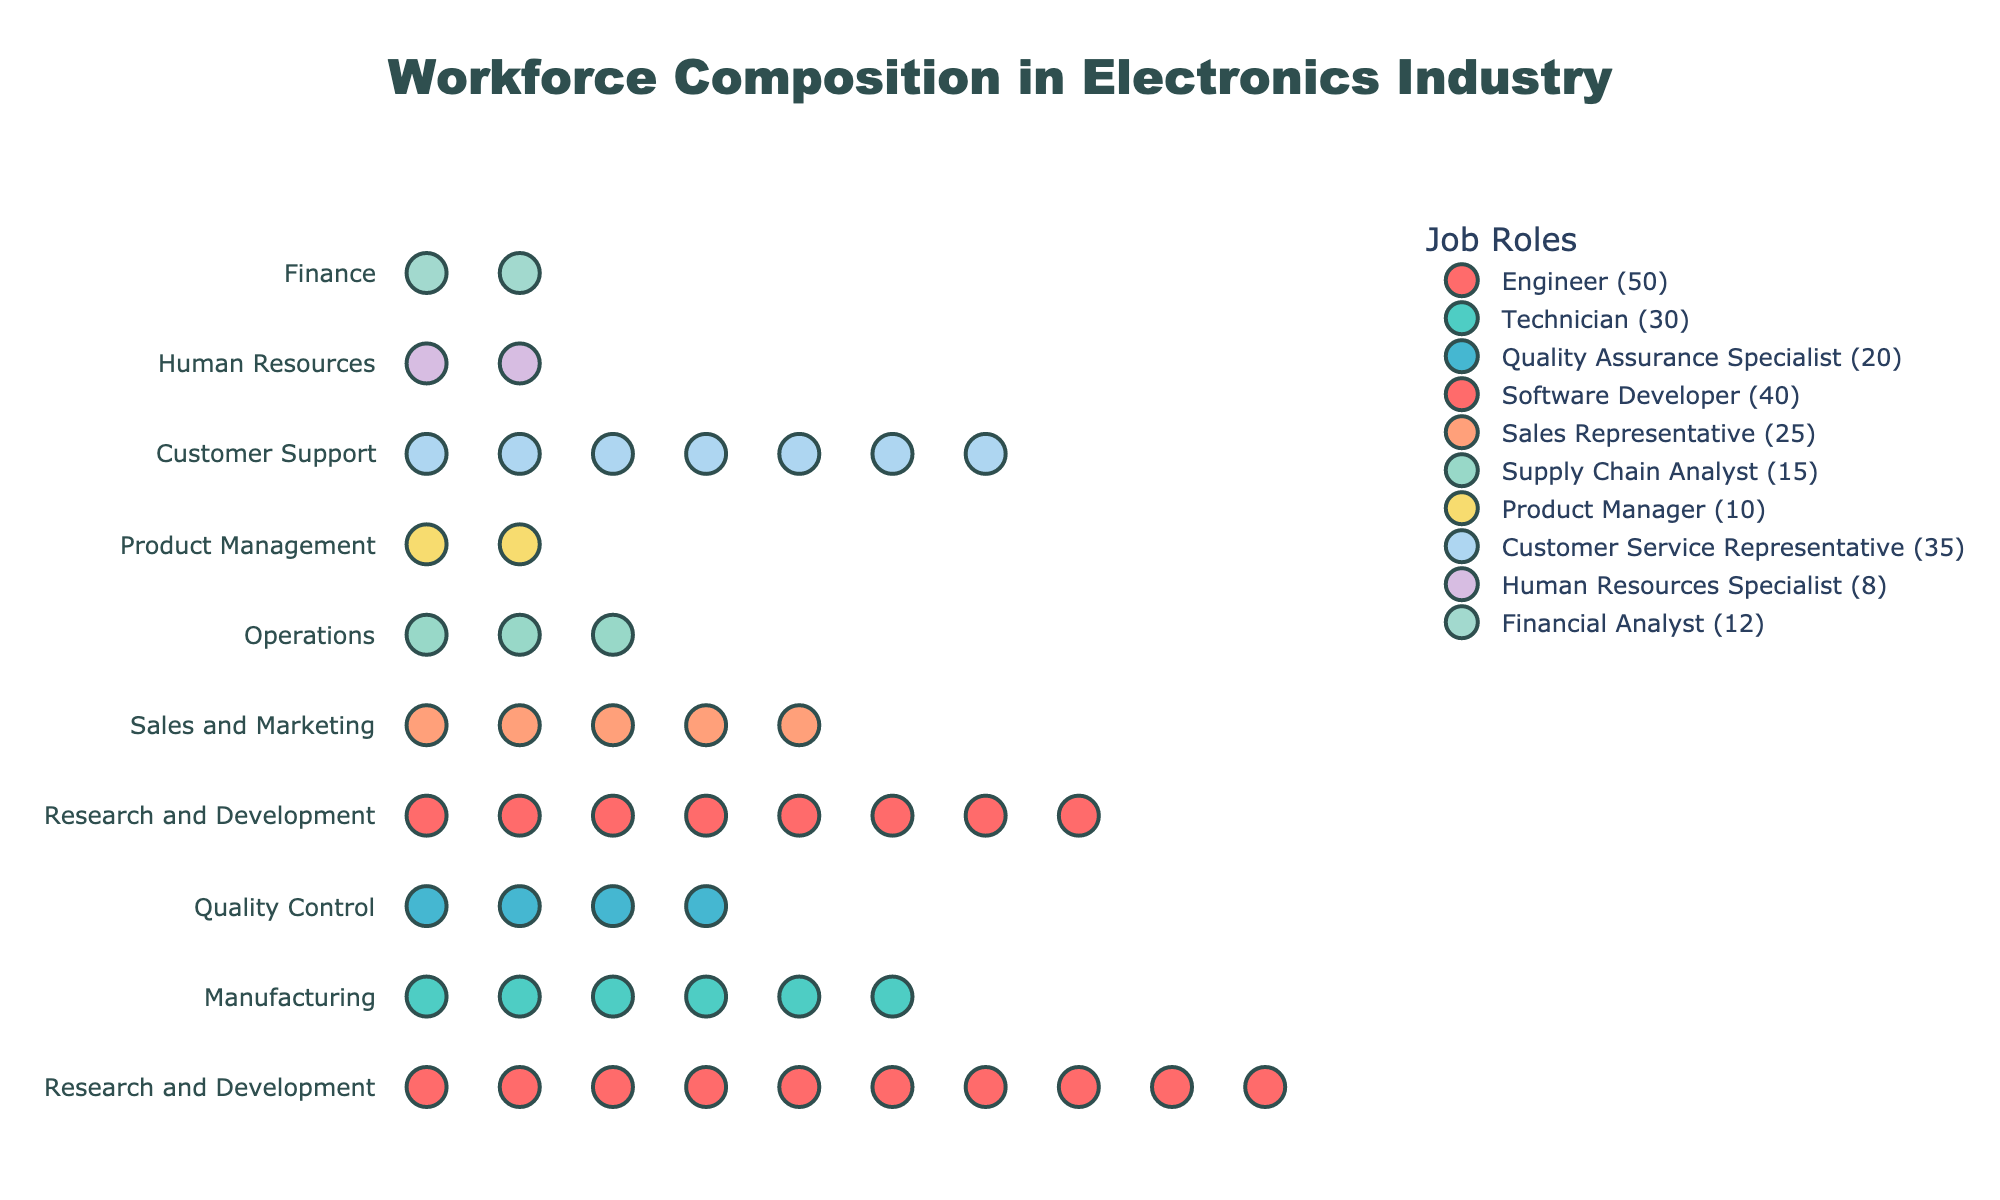what is the title of the plot? The title of the plot is usually located at the top of the figure. In this case, the title is "Workforce Composition in Electronics Industry", as indicated in the code.
Answer: Workforce Composition in Electronics Industry which department has the most job roles displayed? To determine which department has the most job roles, we can look at the distinct job roles listed in the legend and identify their corresponding departments. The department "Research and Development" includes the roles of Engineer and Software Developer.
Answer: Research and Development how many financial analysts are there in the company? To find the number of Financial Analysts, locate the "Financial Analyst" job role in the legend. The number in parentheses indicates the count, which is 12.
Answer: 12 which department has the least representation in terms of job roles? From the dataset, we can see that the "Human Resources" department has only one job role, which is "Human Resources Specialist" with a count of 8. This is the smallest number compared to other departments.
Answer: Human Resources how many more engineers are there compared to technicians? To find the difference, we first identify the counts: 50 Engineers and 30 Technicians. Calculating the difference, 50 - 30 gives 20 more Engineers than Technicians.
Answer: 20 which job role has the second-highest count? By examining the counts, the highest is Engineer with 50. The second-highest is Software Developer with 40.
Answer: Software Developer what are the job roles included in the customer support department? To identify job roles in the Customer Support department, look for any mention of Customer Support in the department labels. The job role listed under Customer Support is "Customer Service Representative."
Answer: Customer Service Representative how many job roles have counts greater than 30? From the dataset, we see the following counts greater than 30: Engineer (50), Technician (30), Software Developer (40), and Customer Service Representative (35). There are 3 job roles with counts greater than 30.
Answer: 3 what is the difference in the number of employees between Quality Control and Product Management departments? The counts for Quality Control and Product Management are 20 and 10, respectively. The difference is calculated as 20 - 10 = 10.
Answer: 10 how do the counts of sales representatives and customer service representatives compare? To compare, Sales Representatives have a count of 25 and Customer Service Representatives have a count of 35. Customer Service Representatives outnumber Sales Representatives by 10.
Answer: 10 